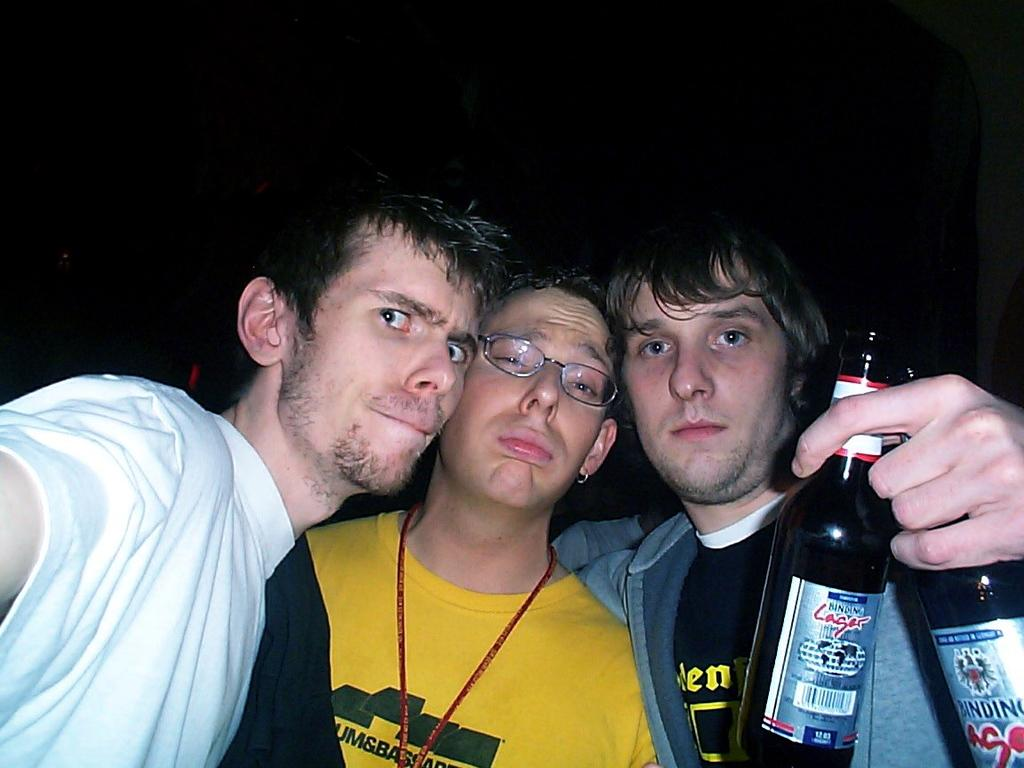How many people are in the image? There are three persons in the image. What are the persons doing in the image? The persons are standing together. What is the person on the right holding in his hand? The person on the right is holding two bottles in his hand. Can you see a duck swimming in the river in the image? There is no duck or river present in the image. What is the uncle doing in the image? The provided facts do not mention an uncle or any specific family relationships, so we cannot determine what the uncle might be doing in the image. 